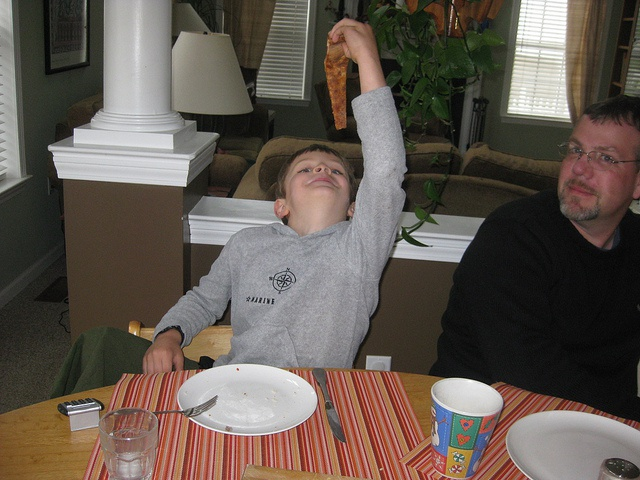Describe the objects in this image and their specific colors. I can see people in darkgray, black, brown, and maroon tones, people in darkgray, gray, and black tones, dining table in darkgray, brown, and olive tones, potted plant in darkgray, black, darkgreen, gray, and maroon tones, and couch in darkgray, black, and gray tones in this image. 